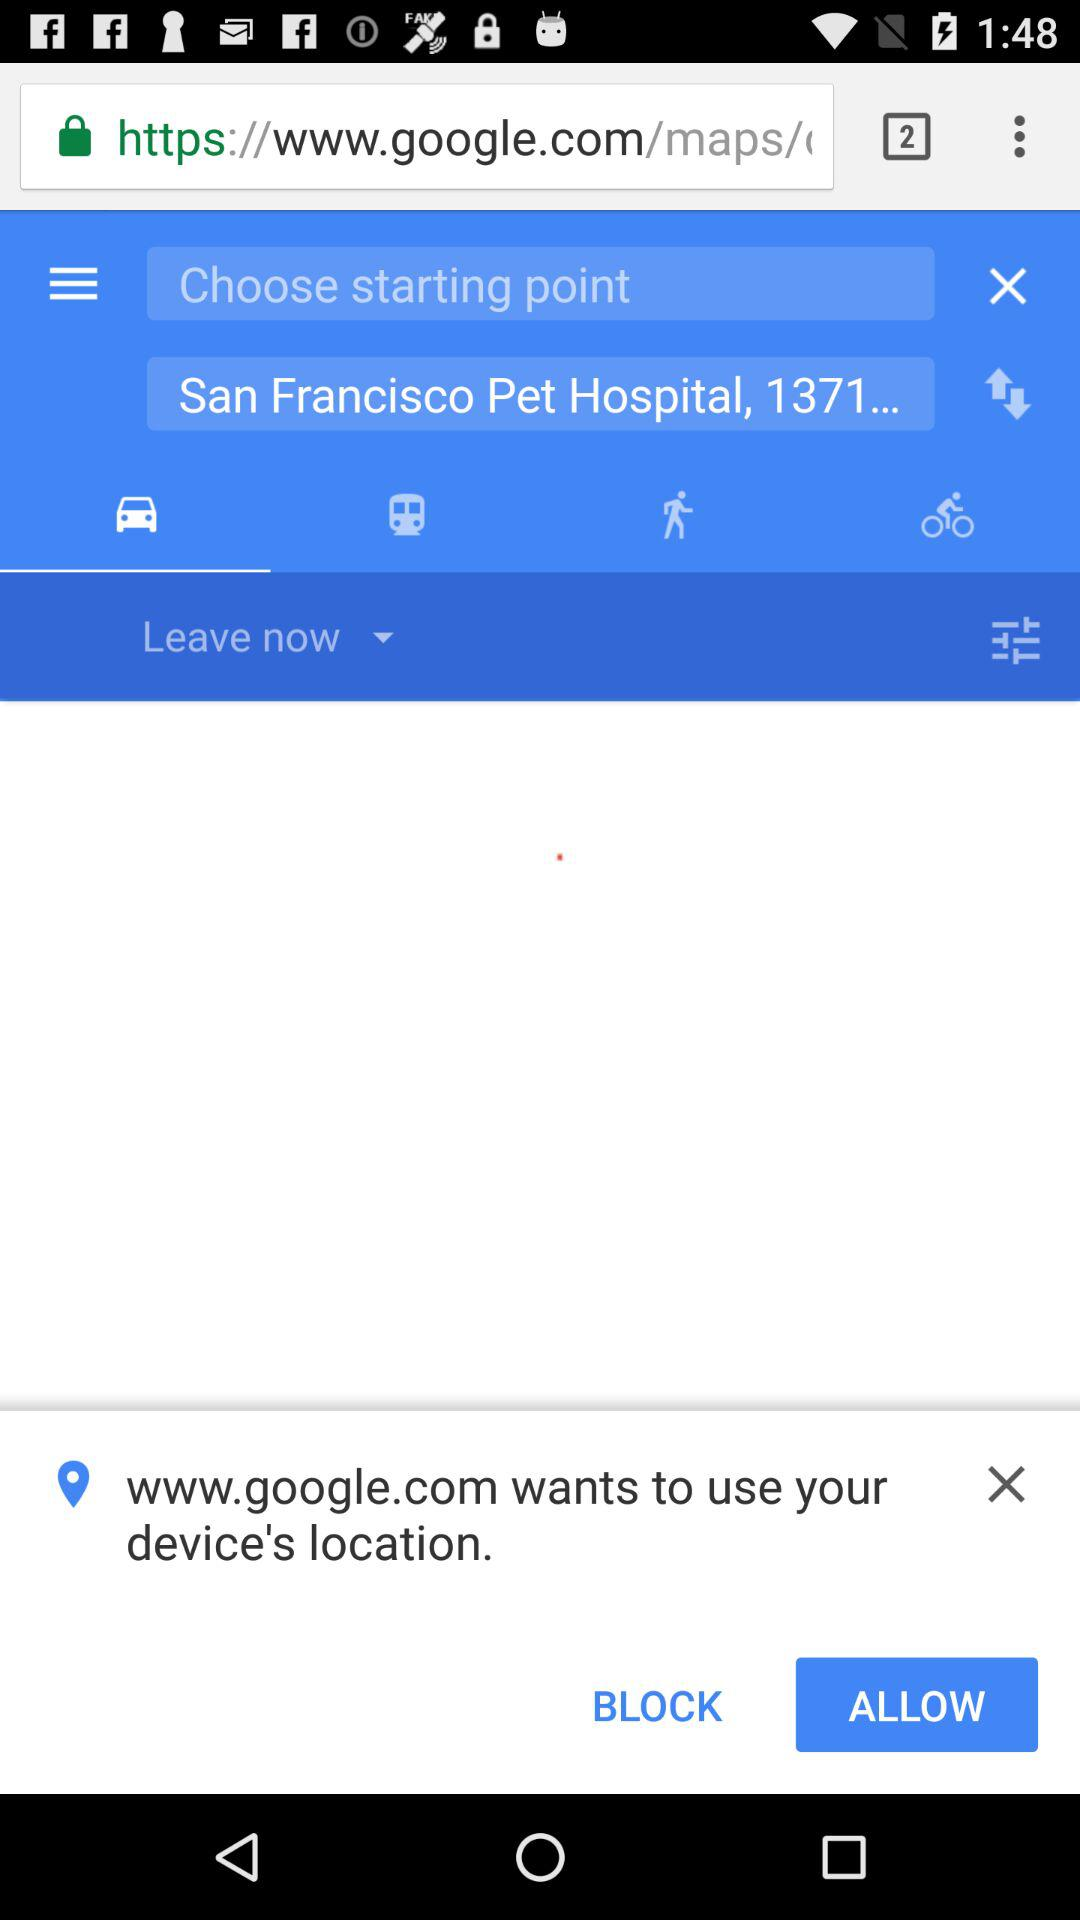What is the destination point? The destination point is "San Francisco Pet Hospital, 1371...". 